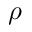<formula> <loc_0><loc_0><loc_500><loc_500>\rho</formula> 